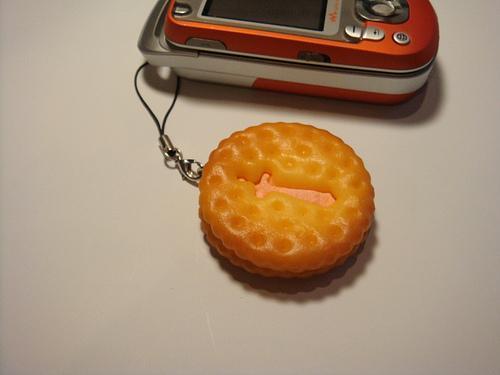How many cell phones are shown?
Give a very brief answer. 1. How many objects in total are shown?
Give a very brief answer. 2. 